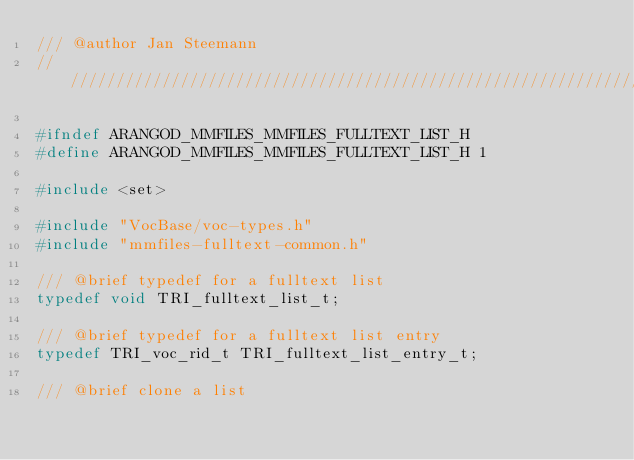<code> <loc_0><loc_0><loc_500><loc_500><_C_>/// @author Jan Steemann
////////////////////////////////////////////////////////////////////////////////

#ifndef ARANGOD_MMFILES_MMFILES_FULLTEXT_LIST_H
#define ARANGOD_MMFILES_MMFILES_FULLTEXT_LIST_H 1

#include <set>

#include "VocBase/voc-types.h"
#include "mmfiles-fulltext-common.h"

/// @brief typedef for a fulltext list
typedef void TRI_fulltext_list_t;

/// @brief typedef for a fulltext list entry
typedef TRI_voc_rid_t TRI_fulltext_list_entry_t;

/// @brief clone a list</code> 